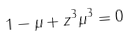Convert formula to latex. <formula><loc_0><loc_0><loc_500><loc_500>1 - \mu + z ^ { 3 } \mu ^ { 3 } = 0</formula> 